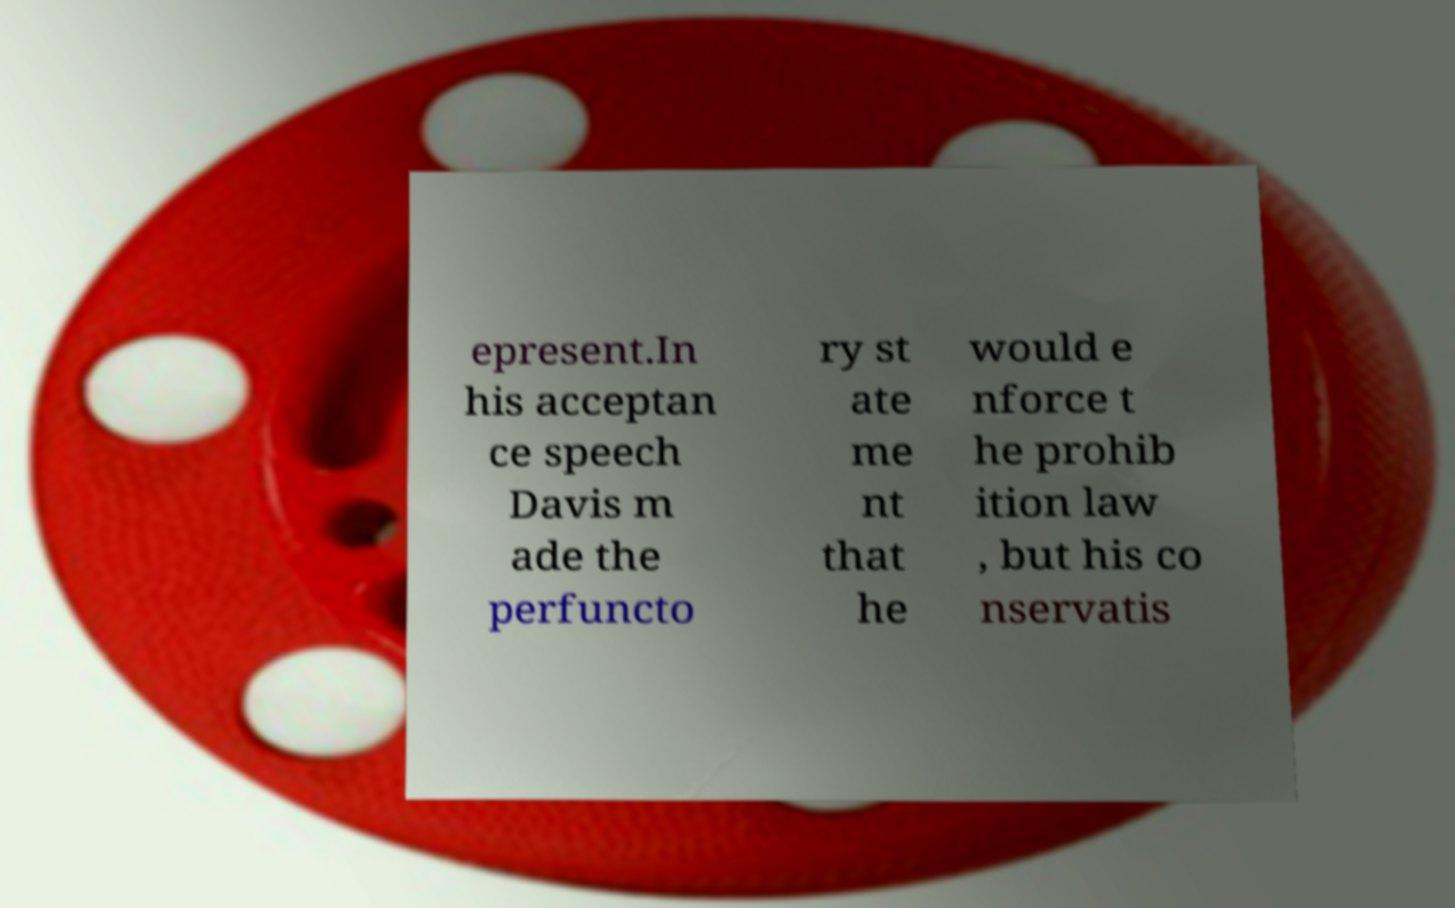Please read and relay the text visible in this image. What does it say? epresent.In his acceptan ce speech Davis m ade the perfuncto ry st ate me nt that he would e nforce t he prohib ition law , but his co nservatis 